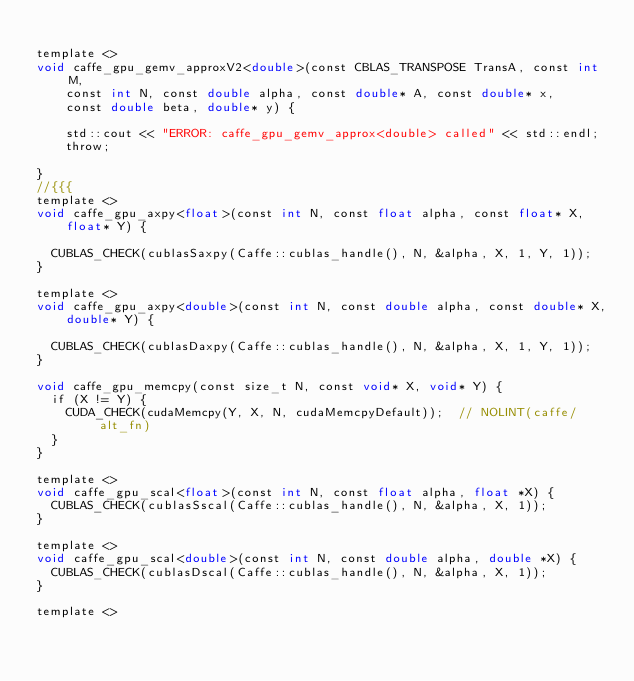Convert code to text. <code><loc_0><loc_0><loc_500><loc_500><_Cuda_>
template <>
void caffe_gpu_gemv_approxV2<double>(const CBLAS_TRANSPOSE TransA, const int M,
    const int N, const double alpha, const double* A, const double* x,
    const double beta, double* y) {
    
    std::cout << "ERROR: caffe_gpu_gemv_approx<double> called" << std::endl;
    throw;
    
}
//{{{
template <>
void caffe_gpu_axpy<float>(const int N, const float alpha, const float* X,
    float* Y) {

  CUBLAS_CHECK(cublasSaxpy(Caffe::cublas_handle(), N, &alpha, X, 1, Y, 1));
}

template <>
void caffe_gpu_axpy<double>(const int N, const double alpha, const double* X,
    double* Y) {

  CUBLAS_CHECK(cublasDaxpy(Caffe::cublas_handle(), N, &alpha, X, 1, Y, 1));
}

void caffe_gpu_memcpy(const size_t N, const void* X, void* Y) {
  if (X != Y) {
    CUDA_CHECK(cudaMemcpy(Y, X, N, cudaMemcpyDefault));  // NOLINT(caffe/alt_fn)
  }
}

template <>
void caffe_gpu_scal<float>(const int N, const float alpha, float *X) {
  CUBLAS_CHECK(cublasSscal(Caffe::cublas_handle(), N, &alpha, X, 1));
}

template <>
void caffe_gpu_scal<double>(const int N, const double alpha, double *X) {
  CUBLAS_CHECK(cublasDscal(Caffe::cublas_handle(), N, &alpha, X, 1));
}

template <></code> 